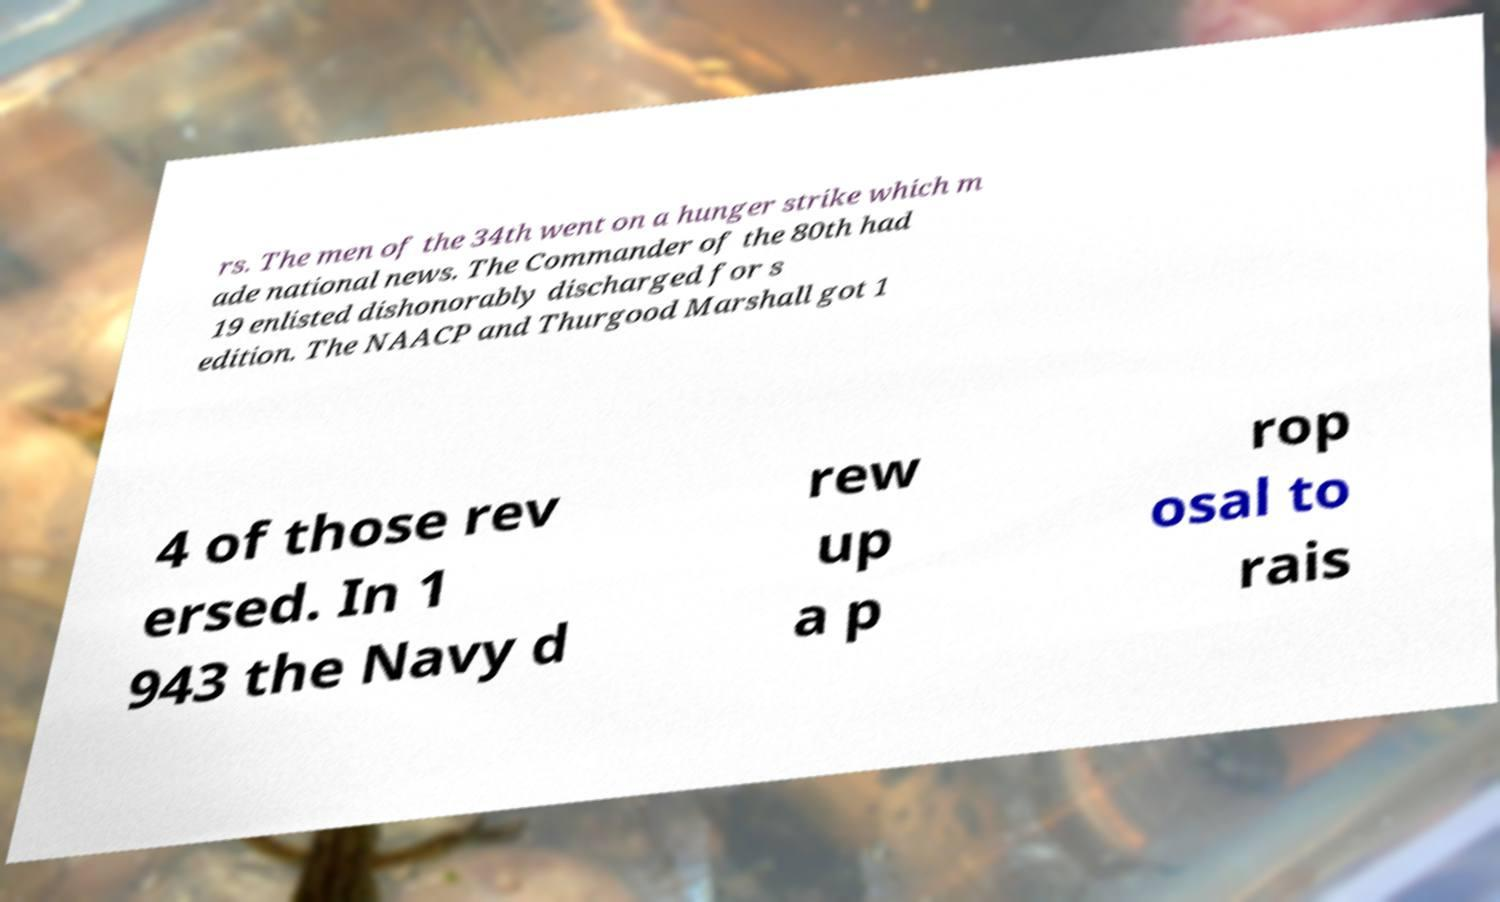For documentation purposes, I need the text within this image transcribed. Could you provide that? rs. The men of the 34th went on a hunger strike which m ade national news. The Commander of the 80th had 19 enlisted dishonorably discharged for s edition. The NAACP and Thurgood Marshall got 1 4 of those rev ersed. In 1 943 the Navy d rew up a p rop osal to rais 